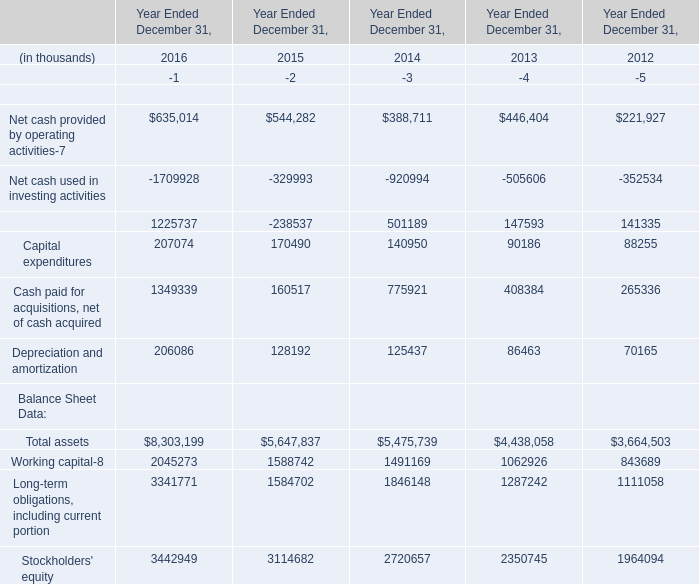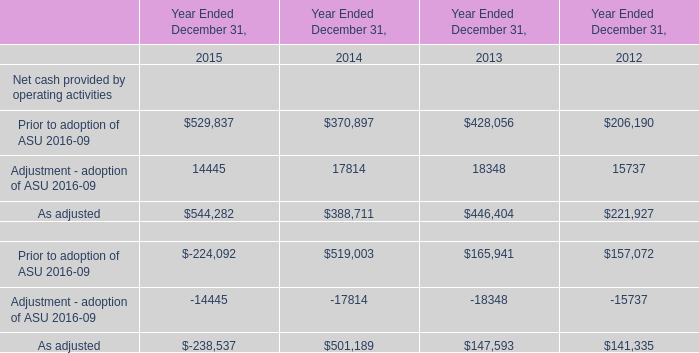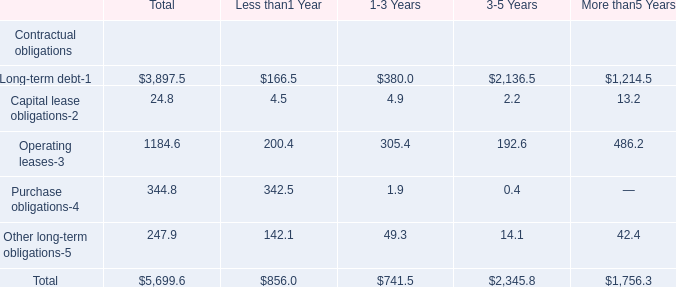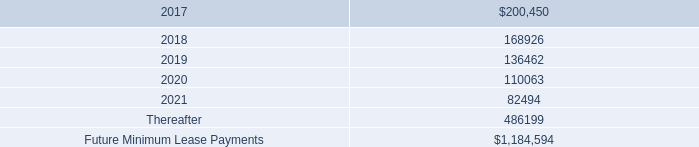what was the percentage change in rental expense for operating leases from 2014 to 2015? 
Computations: ((168.4 - 148.5) / 148.5)
Answer: 0.13401. 